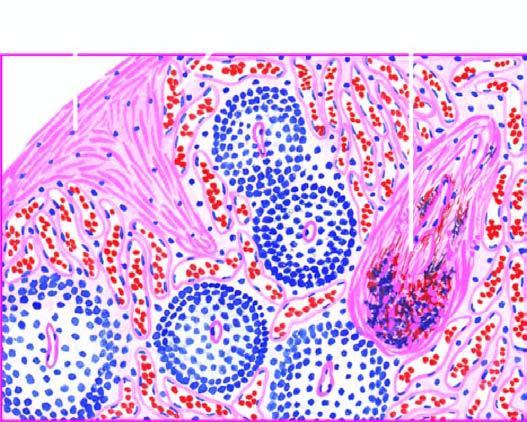what is seen?
Answer the question using a single word or phrase. Gamna-gandy body 